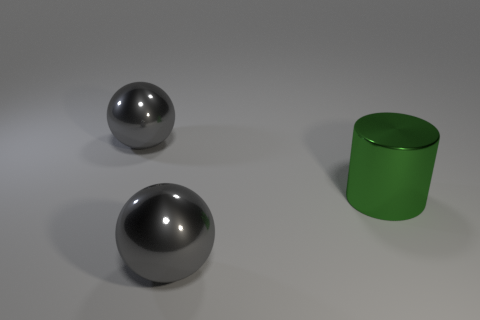Add 1 big metal objects. How many objects exist? 4 Subtract all balls. How many objects are left? 1 Add 1 big green metallic things. How many big green metallic things exist? 2 Subtract 1 green cylinders. How many objects are left? 2 Subtract all big metallic objects. Subtract all big yellow metallic objects. How many objects are left? 0 Add 2 gray spheres. How many gray spheres are left? 4 